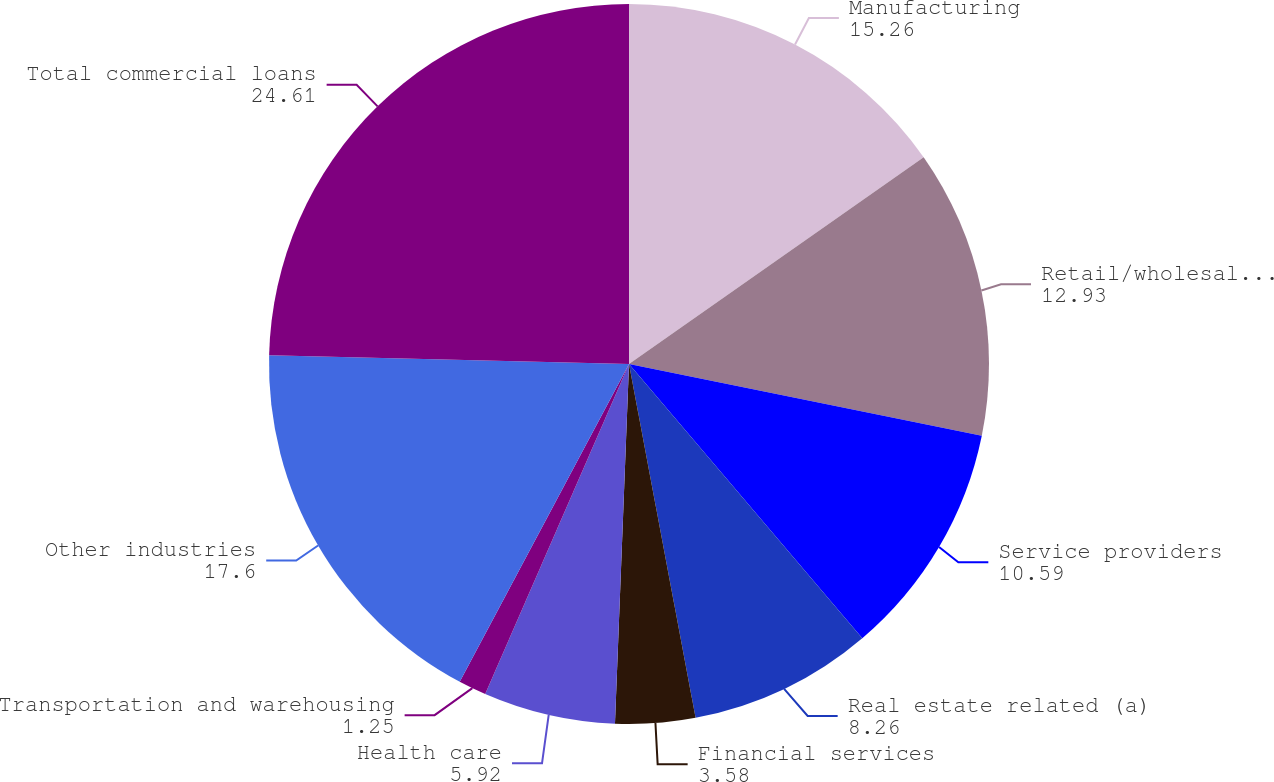Convert chart to OTSL. <chart><loc_0><loc_0><loc_500><loc_500><pie_chart><fcel>Manufacturing<fcel>Retail/wholesale trade<fcel>Service providers<fcel>Real estate related (a)<fcel>Financial services<fcel>Health care<fcel>Transportation and warehousing<fcel>Other industries<fcel>Total commercial loans<nl><fcel>15.26%<fcel>12.93%<fcel>10.59%<fcel>8.26%<fcel>3.58%<fcel>5.92%<fcel>1.25%<fcel>17.6%<fcel>24.61%<nl></chart> 